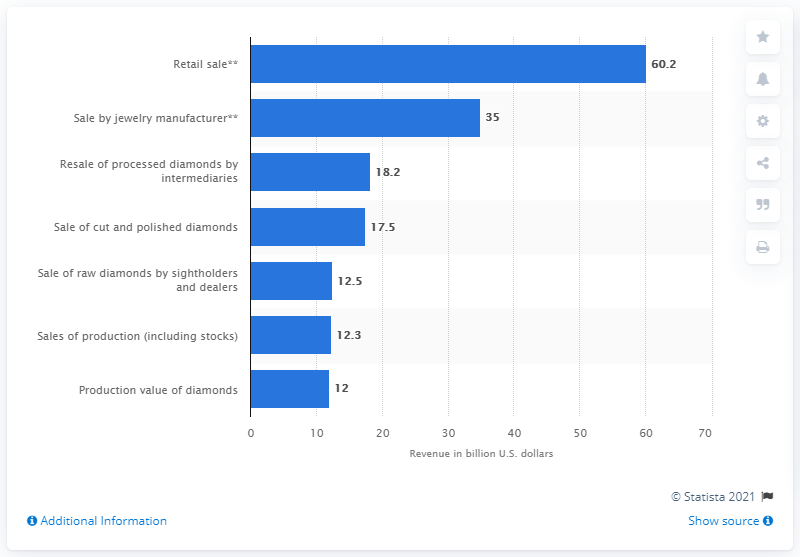Draw attention to some important aspects in this diagram. In 2010, the global production value of diamonds was 12... The sales value of finished diamonds through jewelry manufacturers in 2010 was approximately $35 million. 